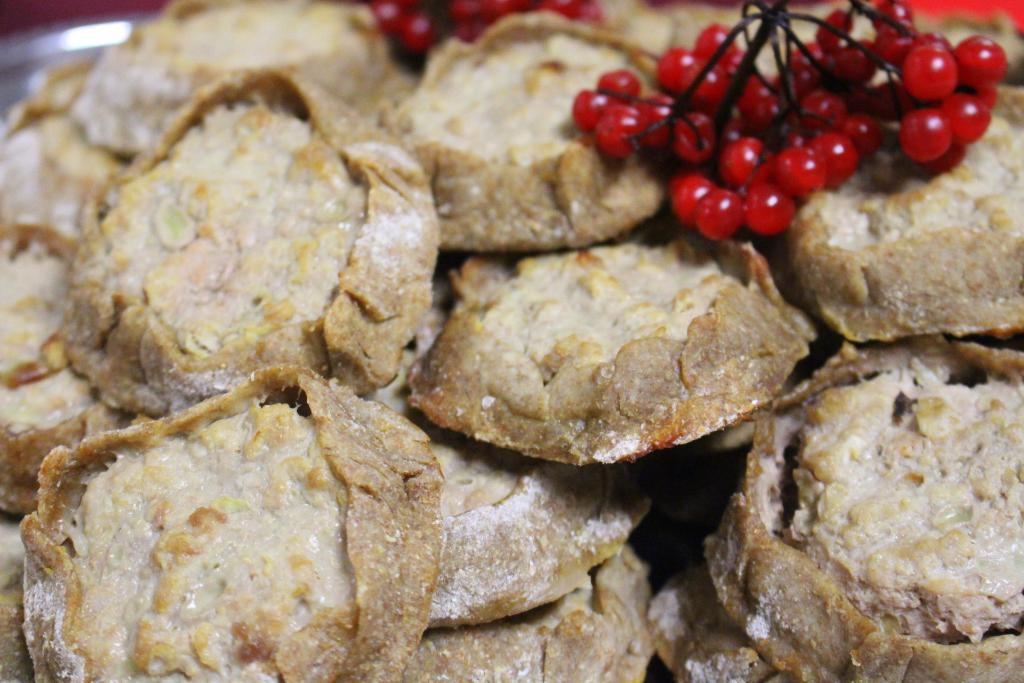What type of food is visible in the image? There are flour puffs and cherries in the image. Can you describe the appearance of the flour puffs? The flour puffs appear to be light and fluffy in the image. What color are the cherries in the image? The cherries in the image are red. What role does the father play in the image? There is no father present in the image, as it only features flour puffs and cherries. What type of bells can be seen in the image? There are no bells present in the image; it only features flour puffs and cherries. 